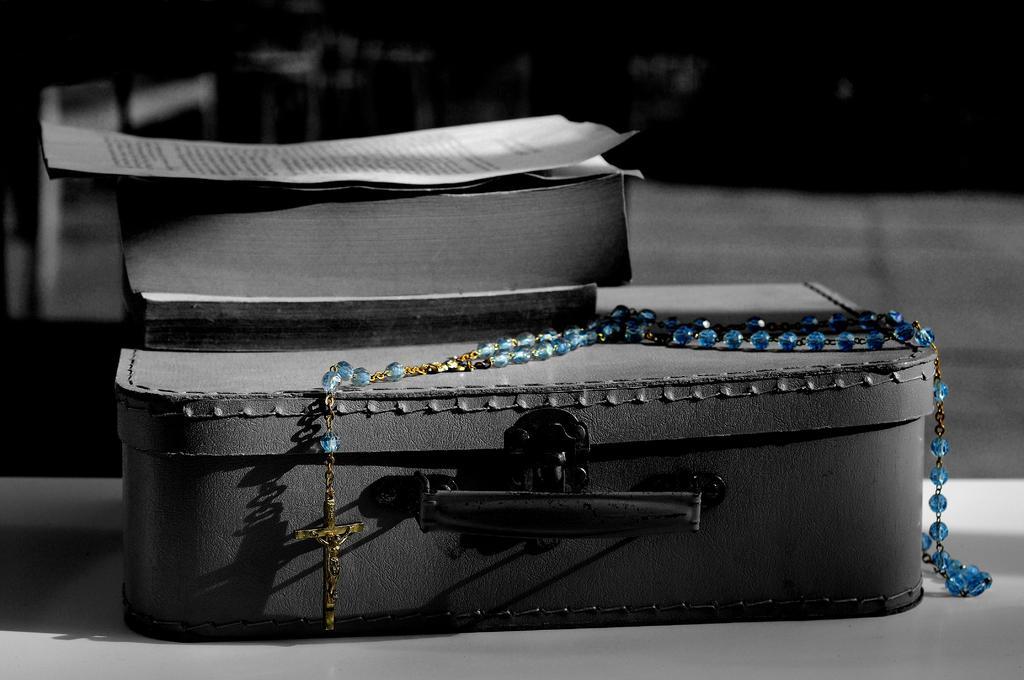Please provide a concise description of this image. This is a black & white picture. In this picture we can see a box and this is a chain with holy cross. Here we can see a holy bible and there is a paper on it. 